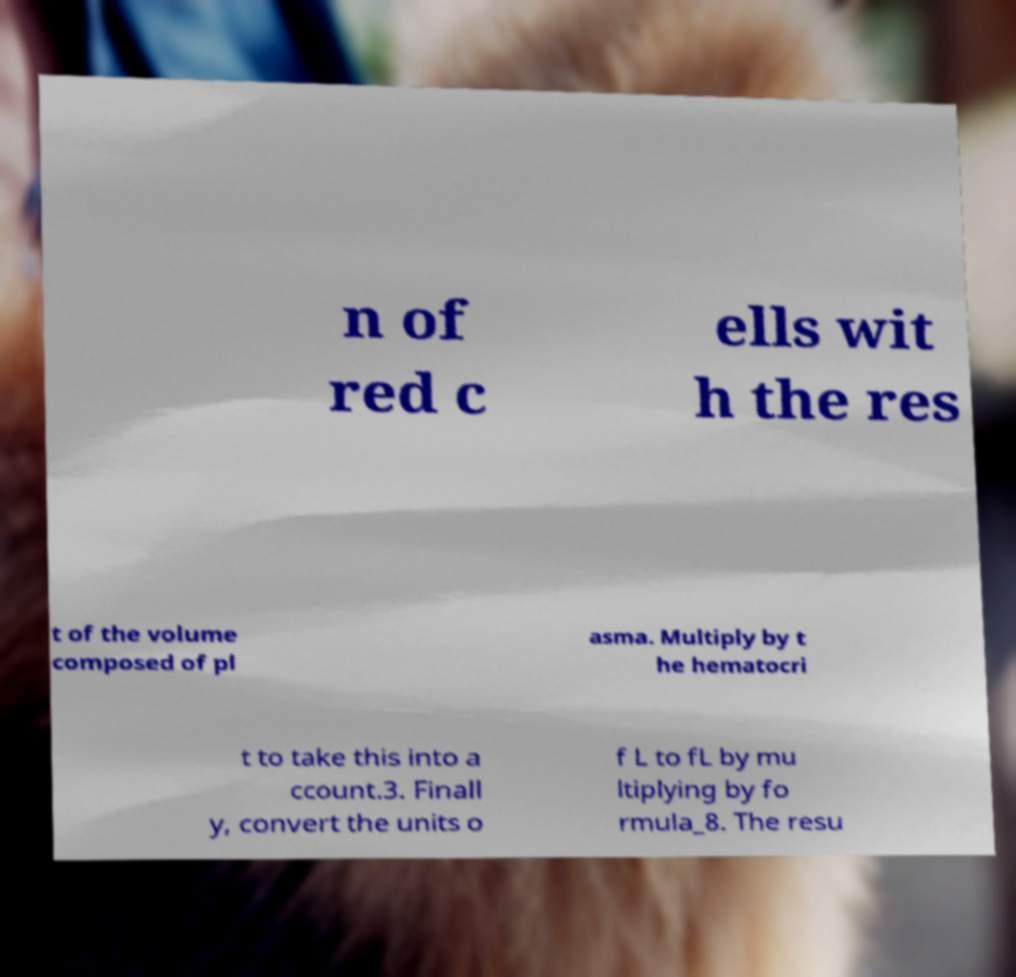For documentation purposes, I need the text within this image transcribed. Could you provide that? n of red c ells wit h the res t of the volume composed of pl asma. Multiply by t he hematocri t to take this into a ccount.3. Finall y, convert the units o f L to fL by mu ltiplying by fo rmula_8. The resu 